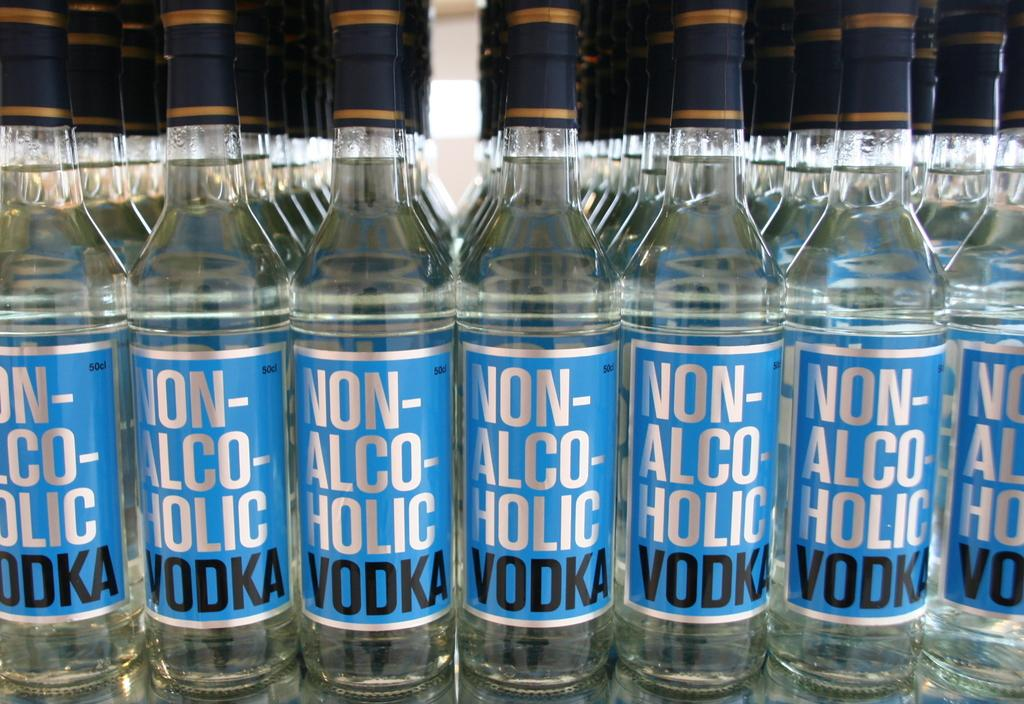Provide a one-sentence caption for the provided image. rows and rows of non alcoholic vodka next to one another. 